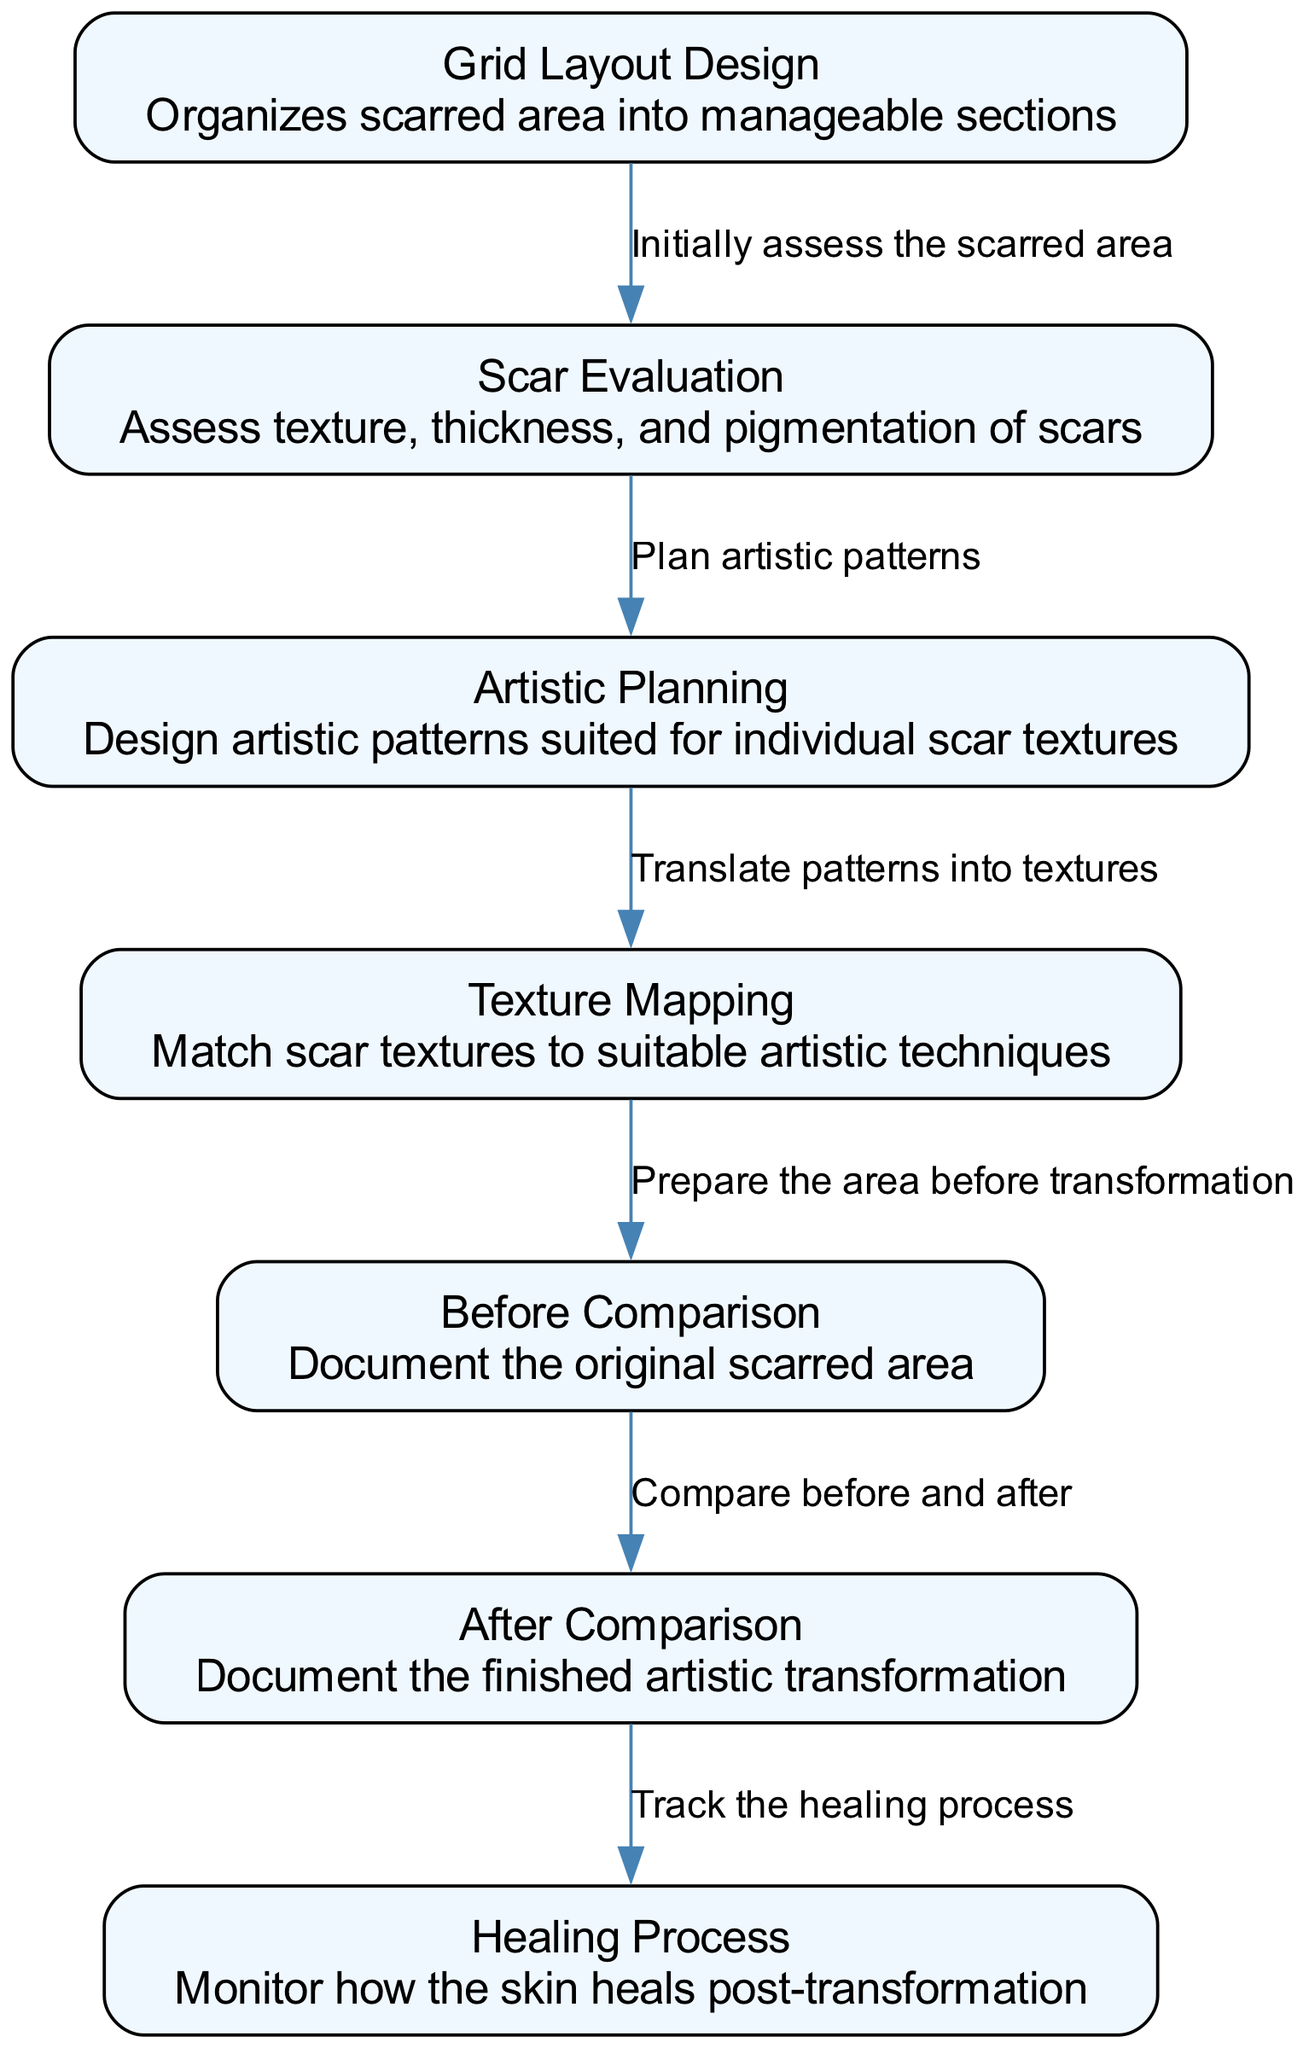What is the first step in the scar transformation process? The first step is represented by the node labeled "Grid Layout Design," which suggests that organizing the scarred area into manageable sections is the starting point.
Answer: Grid Layout Design How many nodes are there in the diagram? By counting the individual elements labeled as nodes within the diagram, we find that there are seven nodes.
Answer: 7 What does "Texture Mapping" relate to directly? The "Texture Mapping" node connects to "Artistic Planning," and it signifies that textures are matched to suitable artistic techniques after planning the patterns.
Answer: Artistic Planning Which step comes after "Before Comparison"? The step that follows "Before Comparison" is "After Comparison," documenting the transformation post-artistic application.
Answer: After Comparison What is the purpose of "Scar Evaluation"? The purpose of "Scar Evaluation" is to assess the texture, thickness, and pigmentation of scars, establishing a foundation for further steps.
Answer: Assess texture, thickness, and pigmentation How does "Artistic Planning" connect to "Texture Mapping"? "Artistic Planning" connects to "Texture Mapping" as it translates artistic patterns designed for the specific scar textures into actionable mapping strategies.
Answer: Translate patterns into textures Which node indicates the documentation of original scars? The node labeled "Before Comparison" is designated for documenting the original scarred area prior to the transformation process.
Answer: Before Comparison What process follows the artistic transformation shown in "After Comparison"? The process that follows the "After Comparison" is the "Healing Process," which involves monitoring how the skin heals after the artistic transformation.
Answer: Healing Process What relationship is represented between "Texture Mapping" and "Before Comparison"? The relationship indicates that after mapping the textures, the area is prepared for transformation, marking a sequential flow from planning to documentation.
Answer: Prepare the area before transformation 